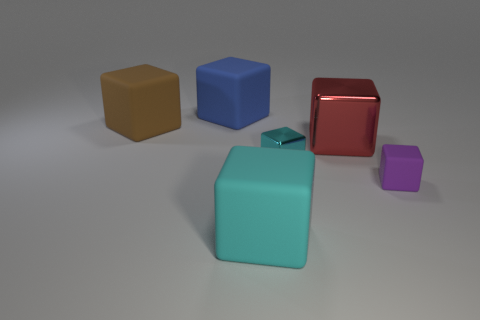Subtract all small metallic cubes. How many cubes are left? 5 Subtract all purple cubes. How many cubes are left? 5 Subtract all gray cubes. Subtract all green balls. How many cubes are left? 6 Add 4 purple matte things. How many objects exist? 10 Add 3 large blue rubber things. How many large blue rubber things exist? 4 Subtract 1 brown blocks. How many objects are left? 5 Subtract all tiny brown rubber cylinders. Subtract all large blue rubber things. How many objects are left? 5 Add 5 large rubber things. How many large rubber things are left? 8 